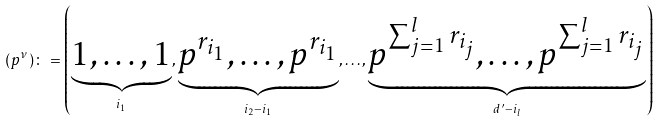<formula> <loc_0><loc_0><loc_500><loc_500>( p ^ { \nu } ) \colon = \left ( \underbrace { 1 , \dots , 1 } _ { i _ { 1 } } , \underbrace { p ^ { r _ { i _ { 1 } } } , \dots , p ^ { r _ { i _ { 1 } } } } _ { i _ { 2 } - i _ { 1 } } , \dots , \underbrace { p ^ { \sum _ { j = 1 } ^ { l } r _ { i _ { j } } } , \dots , p ^ { \sum _ { j = 1 } ^ { l } r _ { i _ { j } } } } _ { d ^ { \prime } - i _ { l } } \right )</formula> 